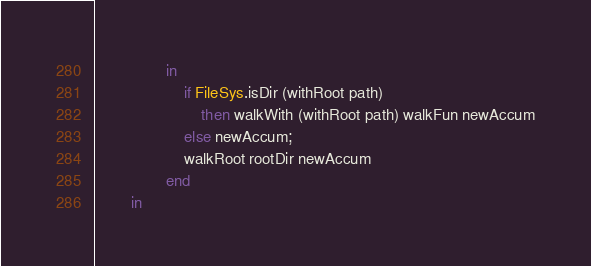<code> <loc_0><loc_0><loc_500><loc_500><_SML_>                in
                    if FileSys.isDir (withRoot path)
                        then walkWith (withRoot path) walkFun newAccum
                    else newAccum;
                    walkRoot rootDir newAccum
                end
        in</code> 